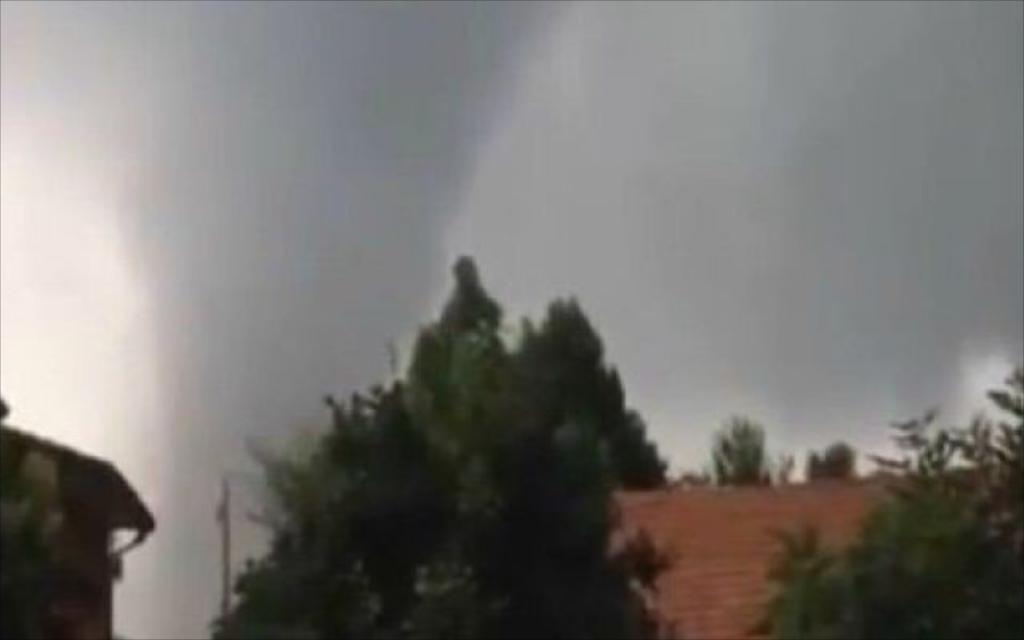What type of vegetation can be seen in the image? There are trees in the image. What structure is visible in the image? There is a roof in the image. What can be seen in the background of the image? The sky is visible in the background of the image. What type of stew is being cooked in the image? There is no stew present in the image; it features trees and a roof. What scientific discovery is depicted in the image? There is no scientific discovery depicted in the image; it features trees, a roof, and the sky. 